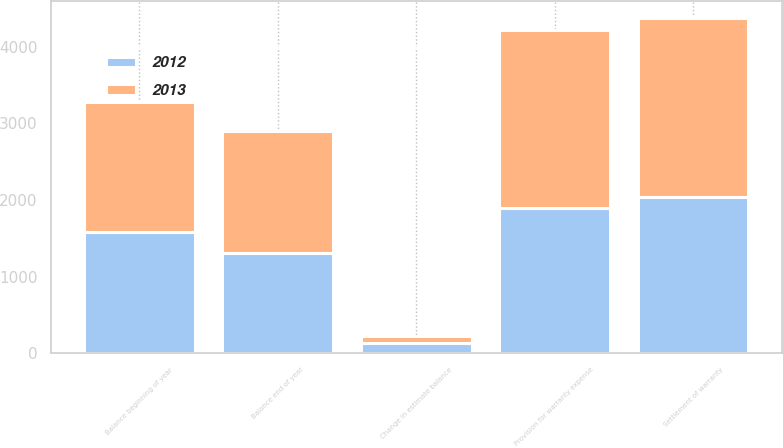<chart> <loc_0><loc_0><loc_500><loc_500><stacked_bar_chart><ecel><fcel>Balance beginning of year<fcel>Provision for warranty expense<fcel>Change in estimate balance<fcel>Settlement of warranty<fcel>Balance end of year<nl><fcel>2012<fcel>1583<fcel>1899<fcel>133<fcel>2035<fcel>1314<nl><fcel>2013<fcel>1693<fcel>2321<fcel>92<fcel>2339<fcel>1583<nl></chart> 